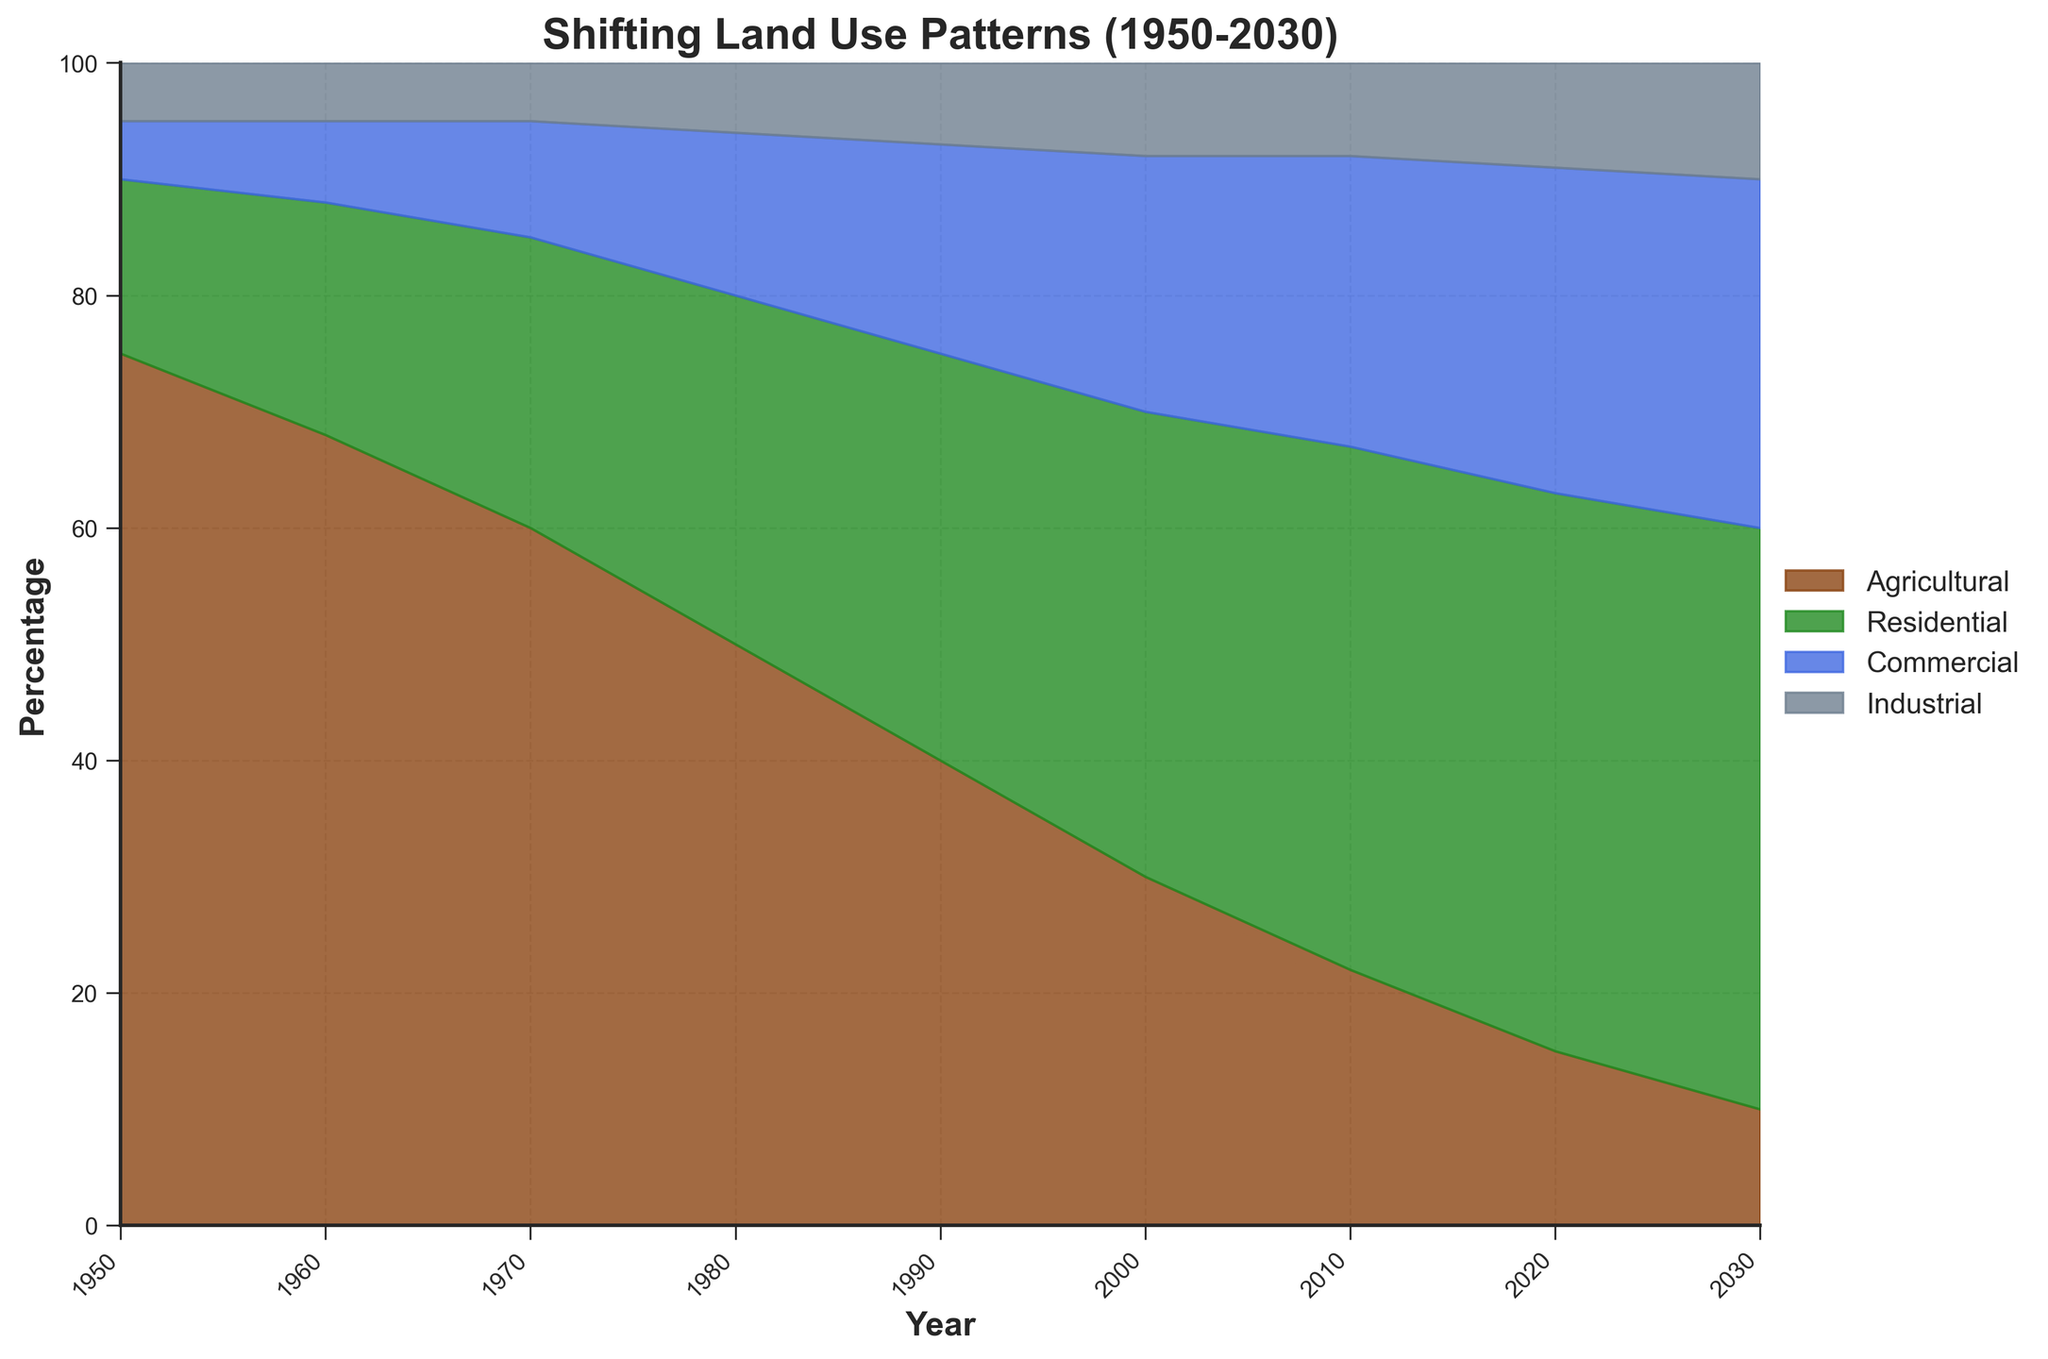What's the title of the figure? The title of the figure is typically found at the top and is used to quickly convey the subject of the chart.
Answer: Shifting Land Use Patterns (1950-2030) What are the four categories displayed in the chart? The categories are usually identified by the legend on the right-hand side of the figure, which lists all the components shown in the fan chart.
Answer: Agricultural, Residential, Commercial, Industrial What is the percentage of Agricultural land use in 1950? To find the percentage of Agricultural land use in 1950, look at the bottom segment of the fan chart at the year 1950 on the x-axis. The Agricultural segment starts at 0% and goes up to 75%, as indicated.
Answer: 75% Which category shows the greatest increase from 1950 to 2030? To determine which category increased the most, compare the height of each segment from the start (1950) to the end (2030). The Residential category increases from 15% to 50%.
Answer: Residential In what year does Residential land use reach 40%? To find the year where Residential land use reaches 40%, look at the green segment in the fan chart and find the point where it intersects with 40% on the y-axis. This intersection happens at the year 2000.
Answer: 2000 By how much did Commercial land use increase from 1950 to 2020? First, identify the Commercial percentage in 1950, which is 5%. Then, find the percentage in 2020, which is 28%. Subtract the former from the latter to calculate the increase: 28% - 5% = 23%.
Answer: 23% How does Industrial land use change over time? Examine the top segment (color for Industrial) throughout the chart from 1950 to 2030. Note the gradual increase from 5% to 10%.
Answer: It increases gradually In which decade does Agricultural land use drop below 50%? Agricultural land use is represented by the brown segment. Focus on identifying the decade when it falls below the 50% line on the y-axis. This change happens between 1970 and 1980.
Answer: 1970-1980 What is the combined percentage of Residential and Commercial land use in 1980? First, locate the percentages for Residential and Commercial in 1980 (30% and 14%, respectively). Add them together: 30% + 14% = 44%.
Answer: 44% Which year shows the smallest gap between Agricultural and Commercial land use? To find this, compare the height difference between the brown and blue segments for each year. The smallest gap appears in 2030, where Agricultural is 10% and Commercial is 30%, a 20% difference.
Answer: 2030 